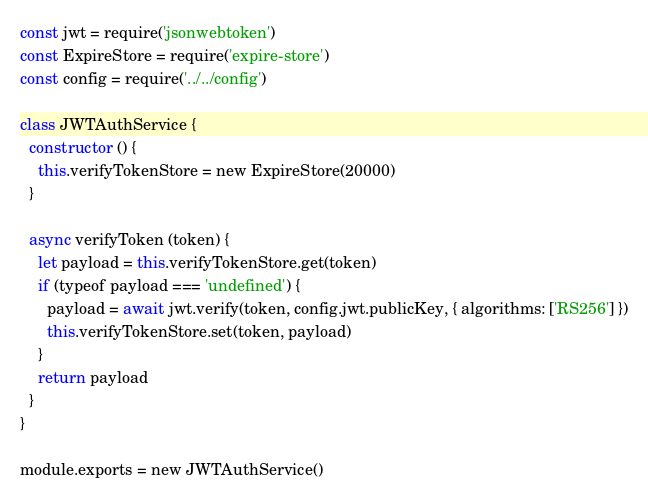Convert code to text. <code><loc_0><loc_0><loc_500><loc_500><_JavaScript_>const jwt = require('jsonwebtoken')
const ExpireStore = require('expire-store')
const config = require('../../config')

class JWTAuthService {
  constructor () {
    this.verifyTokenStore = new ExpireStore(20000)
  }

  async verifyToken (token) {
    let payload = this.verifyTokenStore.get(token)
    if (typeof payload === 'undefined') {
      payload = await jwt.verify(token, config.jwt.publicKey, { algorithms: ['RS256'] })
      this.verifyTokenStore.set(token, payload)
    }
    return payload
  }
}

module.exports = new JWTAuthService()
</code> 